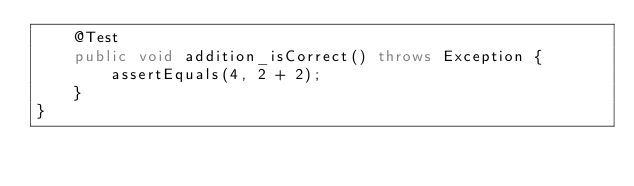<code> <loc_0><loc_0><loc_500><loc_500><_Java_>    @Test
    public void addition_isCorrect() throws Exception {
        assertEquals(4, 2 + 2);
    }
}</code> 